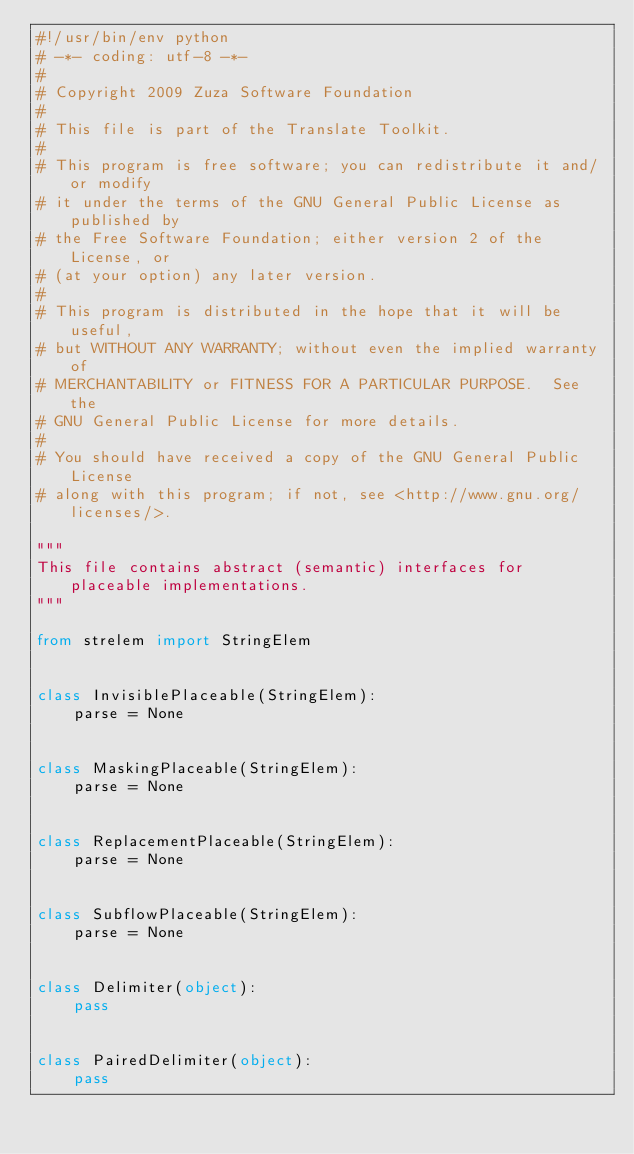Convert code to text. <code><loc_0><loc_0><loc_500><loc_500><_Python_>#!/usr/bin/env python
# -*- coding: utf-8 -*-
#
# Copyright 2009 Zuza Software Foundation
#
# This file is part of the Translate Toolkit.
#
# This program is free software; you can redistribute it and/or modify
# it under the terms of the GNU General Public License as published by
# the Free Software Foundation; either version 2 of the License, or
# (at your option) any later version.
#
# This program is distributed in the hope that it will be useful,
# but WITHOUT ANY WARRANTY; without even the implied warranty of
# MERCHANTABILITY or FITNESS FOR A PARTICULAR PURPOSE.  See the
# GNU General Public License for more details.
#
# You should have received a copy of the GNU General Public License
# along with this program; if not, see <http://www.gnu.org/licenses/>.

"""
This file contains abstract (semantic) interfaces for placeable implementations.
"""

from strelem import StringElem


class InvisiblePlaceable(StringElem):
    parse = None


class MaskingPlaceable(StringElem):
    parse = None


class ReplacementPlaceable(StringElem):
    parse = None


class SubflowPlaceable(StringElem):
    parse = None


class Delimiter(object):
    pass


class PairedDelimiter(object):
    pass
</code> 